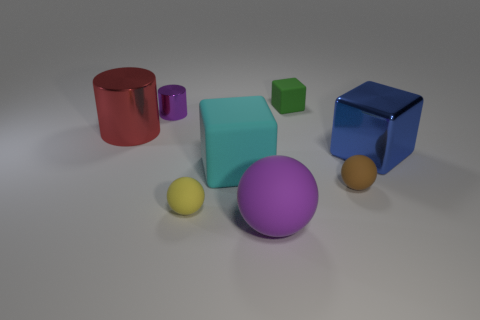Add 2 small blocks. How many objects exist? 10 Subtract all blocks. How many objects are left? 5 Subtract 0 gray balls. How many objects are left? 8 Subtract all large blue shiny things. Subtract all big red objects. How many objects are left? 6 Add 7 brown rubber balls. How many brown rubber balls are left? 8 Add 4 big cylinders. How many big cylinders exist? 5 